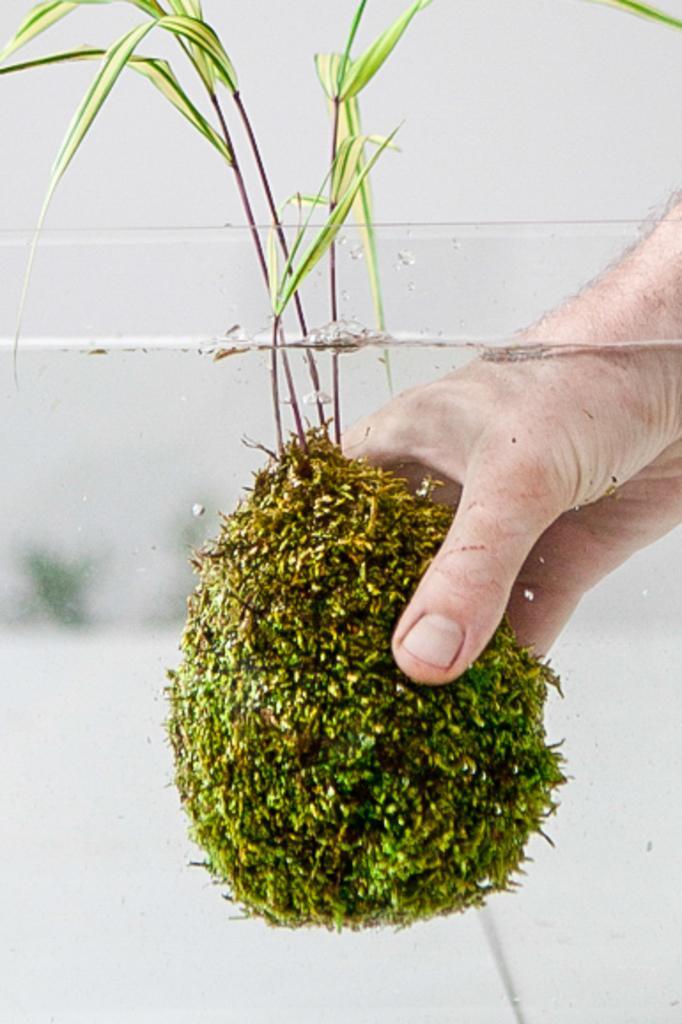Could you give a brief overview of what you see in this image? In this picture, we see the hand of a person is holding a plant in the water. At the bottom, we see the water in a glass tub. In the background, we see a wall in white color. 